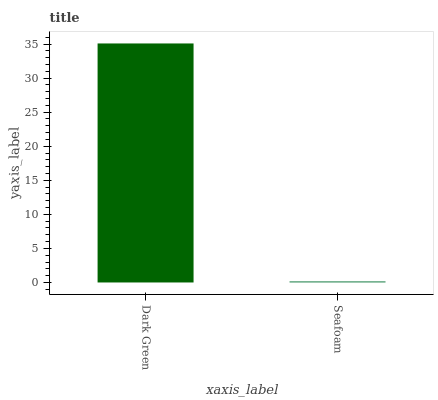Is Seafoam the minimum?
Answer yes or no. Yes. Is Dark Green the maximum?
Answer yes or no. Yes. Is Seafoam the maximum?
Answer yes or no. No. Is Dark Green greater than Seafoam?
Answer yes or no. Yes. Is Seafoam less than Dark Green?
Answer yes or no. Yes. Is Seafoam greater than Dark Green?
Answer yes or no. No. Is Dark Green less than Seafoam?
Answer yes or no. No. Is Dark Green the high median?
Answer yes or no. Yes. Is Seafoam the low median?
Answer yes or no. Yes. Is Seafoam the high median?
Answer yes or no. No. Is Dark Green the low median?
Answer yes or no. No. 